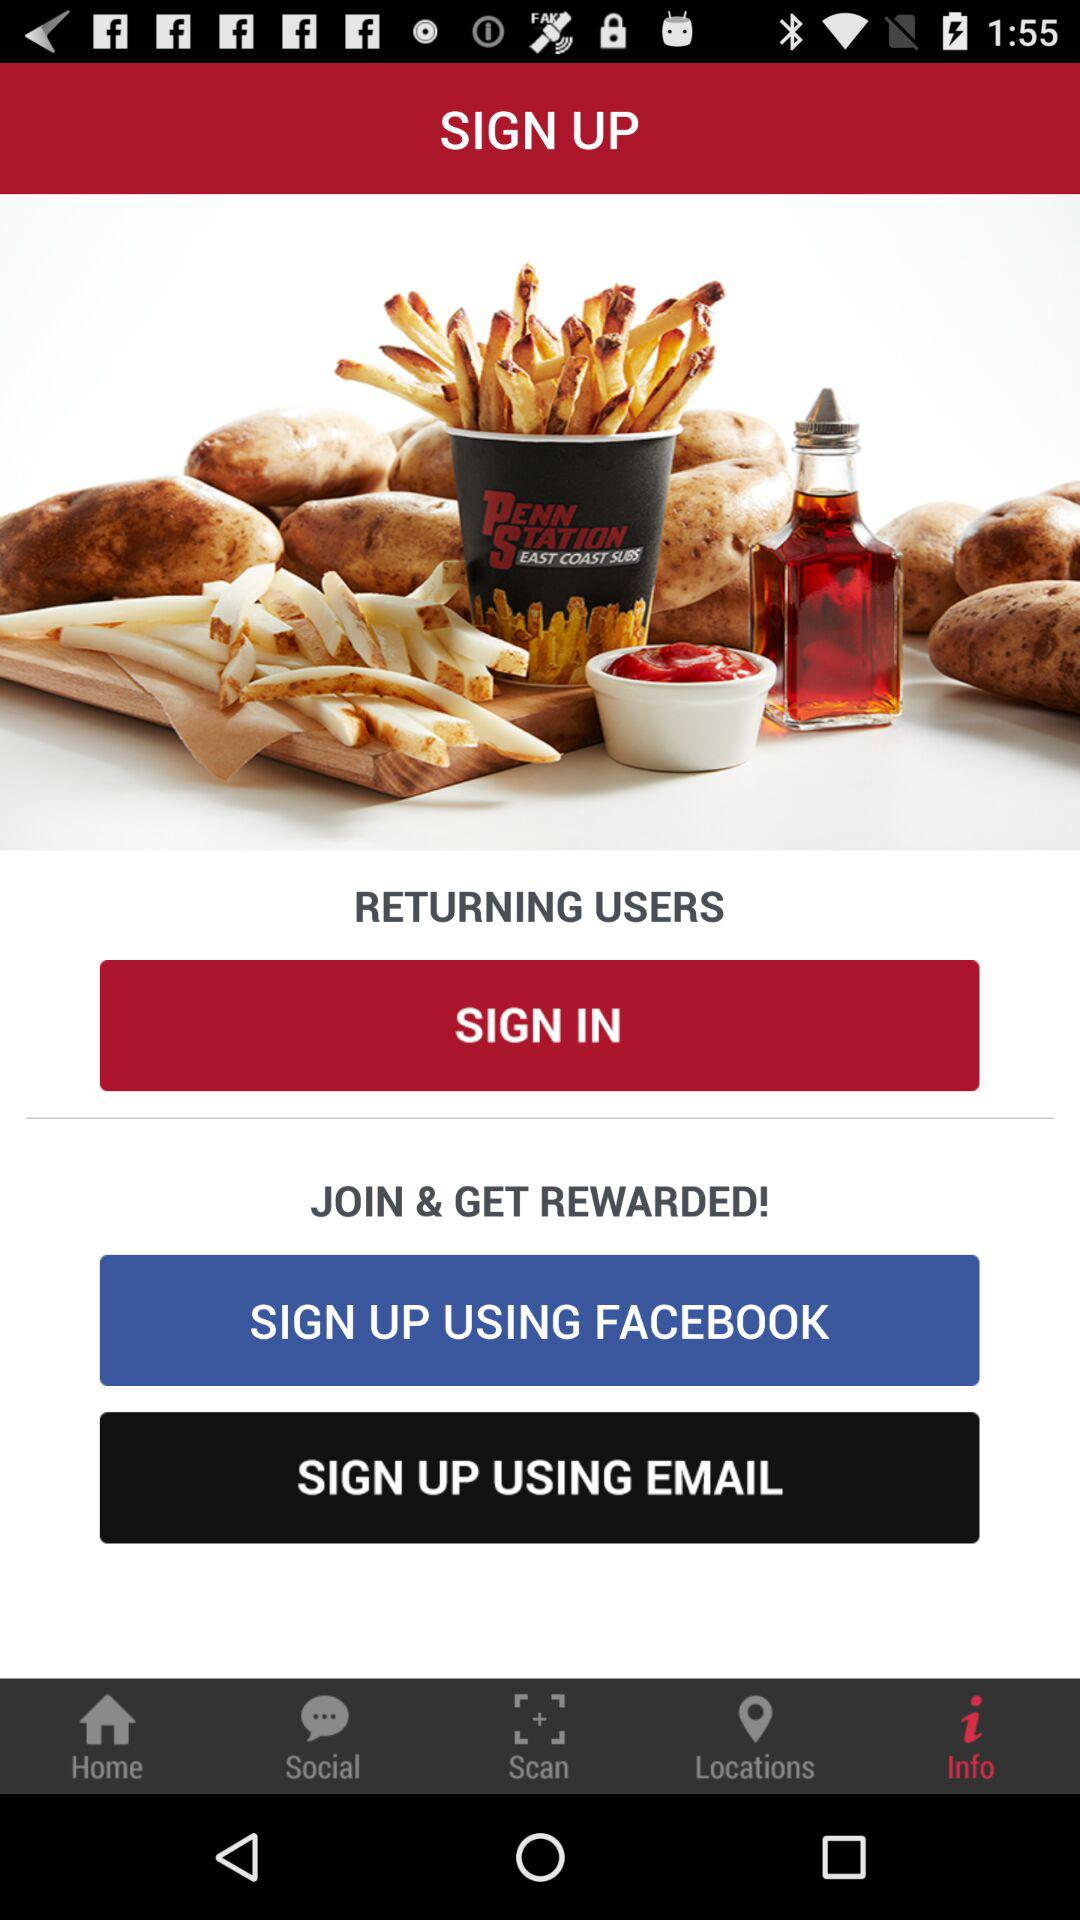Through what app can we sign up? You can sign up through "FACEBOOK". 